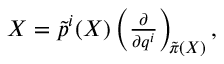<formula> <loc_0><loc_0><loc_500><loc_500>\begin{array} { r } { X = \tilde { p } ^ { i } ( X ) \left ( \frac { \partial } { \partial { q } ^ { i } } \right ) _ { \neg m e d s p a c e \tilde { \pi } ( X ) } , } \end{array}</formula> 